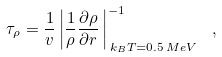<formula> <loc_0><loc_0><loc_500><loc_500>\tau _ { \rho } = \frac { 1 } { v } \left | \frac { 1 } { \rho } \frac { \partial \rho } { \partial r } \, \right | ^ { - 1 } _ { \, k _ { B } T = 0 . 5 \, M e V } \ ,</formula> 